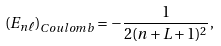Convert formula to latex. <formula><loc_0><loc_0><loc_500><loc_500>\left ( E _ { n \ell } \right ) _ { C o u l o m b } = - \frac { 1 } { 2 ( n + L + 1 ) ^ { 2 } } ,</formula> 